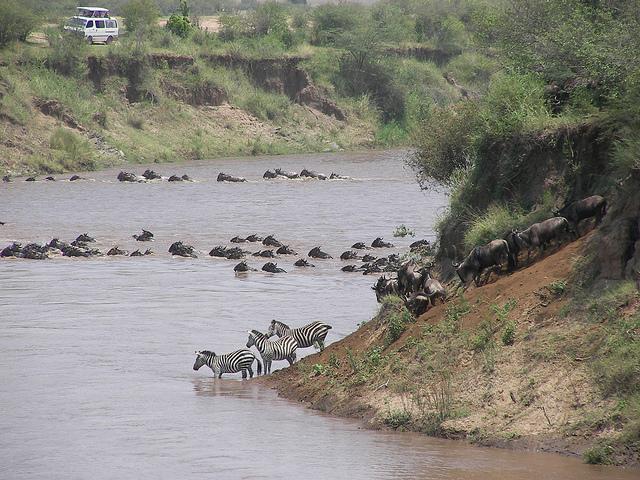How many vehicles do you see?
Give a very brief answer. 1. 